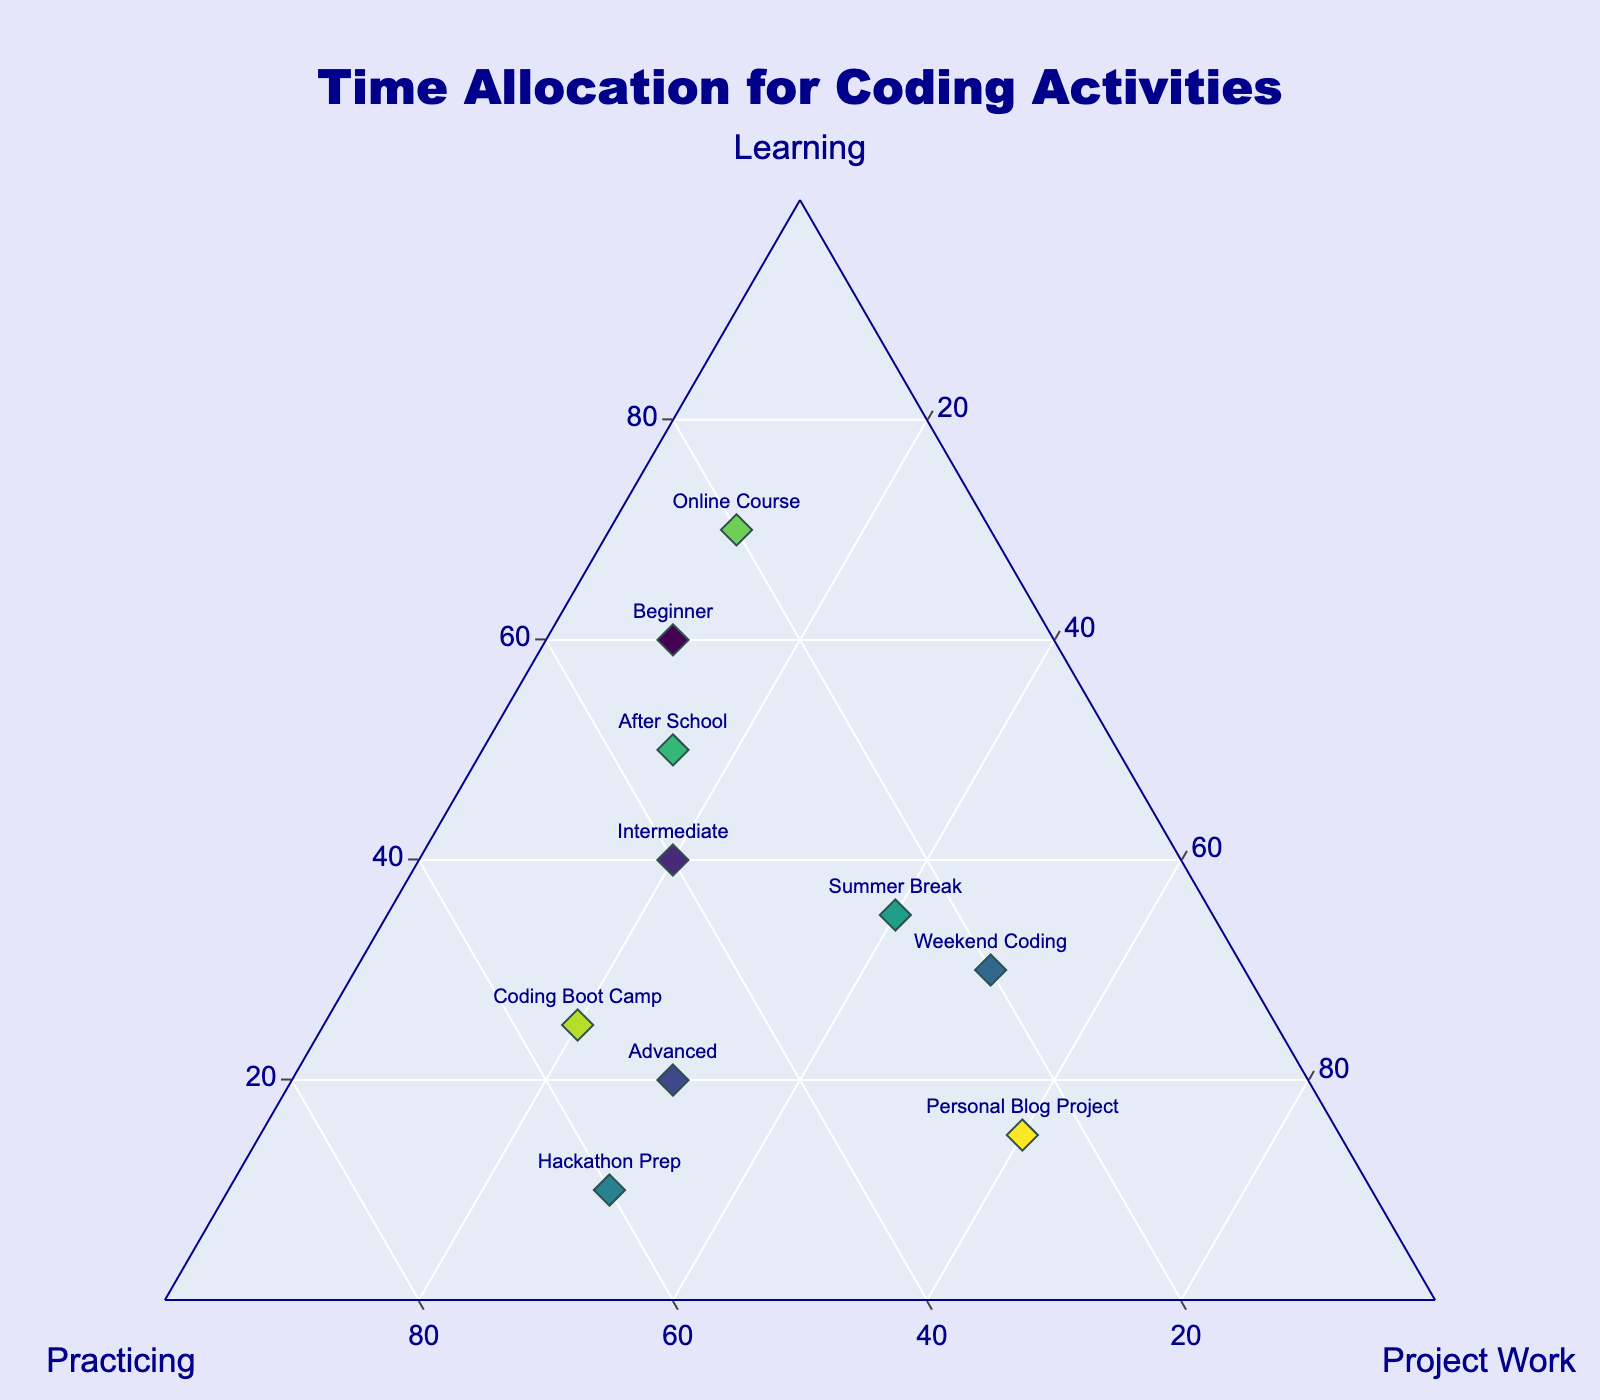what's the title of the plot? The title of the plot is displayed at the top center of the figure. By looking at the text in that position, we can read the title.
Answer: Time Allocation for Coding Activities How many data points are shown on the plot? Each data point represents one activity listed in the dataset, and each data point is marked by a diamond symbol on the plot. By counting these markers, we can determine the number of data points.
Answer: 10 Which activity spends the most time on Project Work overall? To find the activity with the most time spent on Project Work, we look for the data point located closest to the Project Work axis. The visualization shows the percentage allocation among Learning, Practicing, and Project Work for each activity.
Answer: Personal Blog Project How is the time split for Weekend Coding? To determine the time allocation for Weekend Coding, locate the corresponding data point and read off the values of Learning, Practicing, and Project Work. Each of these portions sums up to 100%.
Answer: 30% Learning, 20% Practicing, 50% Project Work Which activity has more Practicing time, Hackathon Prep or Intermediate? Compare the Practicing values of both Hackathon Prep and Intermediate. These values are located along the Practicing axis, and we compare the positions of the corresponding markers.
Answer: Hackathon Prep Identify the activity with roughly equal time allocated to Learning and Practicing. To find this, look for a data point where the values of Learning and Practicing are close to each other. By examining the markers, we see that the activity with nearest equal values is found.
Answer: Intermediate What is the general time allocation trend for Advanced activities? Locate the marker for the Advanced activity and observe its position relative to the Learning, Practicing, and Project Work axes. The trend indicates a higher portion dedicated to Practicing.
Answer: 20% Learning, 50% Practicing, 30% Project Work Between After School and Online Course, which activity spends a greater percentage on Learning? Compare the percentages of Learning for both After School and Online Course by examining their positions along the Learning axis. The activity closer to the Learning apex has a higher percentage.
Answer: Online Course 